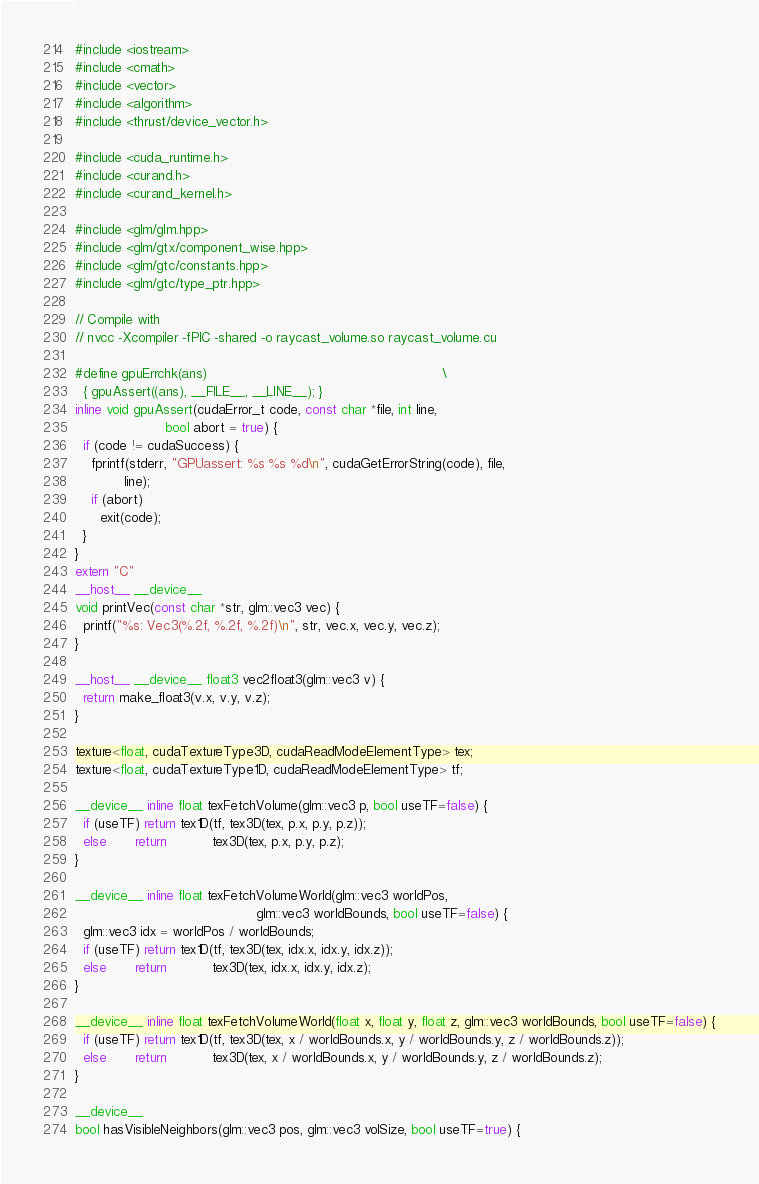Convert code to text. <code><loc_0><loc_0><loc_500><loc_500><_Cuda_>#include <iostream>
#include <cmath>
#include <vector>
#include <algorithm>
#include <thrust/device_vector.h>

#include <cuda_runtime.h>
#include <curand.h>
#include <curand_kernel.h>

#include <glm/glm.hpp>
#include <glm/gtx/component_wise.hpp>
#include <glm/gtc/constants.hpp>
#include <glm/gtc/type_ptr.hpp>

// Compile with
// nvcc -Xcompiler -fPIC -shared -o raycast_volume.so raycast_volume.cu

#define gpuErrchk(ans)                                                         \
  { gpuAssert((ans), __FILE__, __LINE__); }
inline void gpuAssert(cudaError_t code, const char *file, int line,
                      bool abort = true) {
  if (code != cudaSuccess) {
    fprintf(stderr, "GPUassert: %s %s %d\n", cudaGetErrorString(code), file,
            line);
    if (abort)
      exit(code);
  }
}
extern "C"
__host__ __device__
void printVec(const char *str, glm::vec3 vec) {
  printf("%s: Vec3(%.2f, %.2f, %.2f)\n", str, vec.x, vec.y, vec.z);
}

__host__ __device__ float3 vec2float3(glm::vec3 v) {
  return make_float3(v.x, v.y, v.z);
}

texture<float, cudaTextureType3D, cudaReadModeElementType> tex;
texture<float, cudaTextureType1D, cudaReadModeElementType> tf;

__device__ inline float texFetchVolume(glm::vec3 p, bool useTF=false) {
  if (useTF) return tex1D(tf, tex3D(tex, p.x, p.y, p.z));
  else       return           tex3D(tex, p.x, p.y, p.z);
}

__device__ inline float texFetchVolumeWorld(glm::vec3 worldPos,
                                            glm::vec3 worldBounds, bool useTF=false) {
  glm::vec3 idx = worldPos / worldBounds;
  if (useTF) return tex1D(tf, tex3D(tex, idx.x, idx.y, idx.z));
  else       return           tex3D(tex, idx.x, idx.y, idx.z);
}

__device__ inline float texFetchVolumeWorld(float x, float y, float z, glm::vec3 worldBounds, bool useTF=false) {
  if (useTF) return tex1D(tf, tex3D(tex, x / worldBounds.x, y / worldBounds.y, z / worldBounds.z));
  else       return           tex3D(tex, x / worldBounds.x, y / worldBounds.y, z / worldBounds.z);
}

__device__
bool hasVisibleNeighbors(glm::vec3 pos, glm::vec3 volSize, bool useTF=true) {</code> 